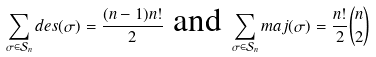Convert formula to latex. <formula><loc_0><loc_0><loc_500><loc_500>\sum _ { \sigma \in \mathcal { S } _ { n } } d e s ( \sigma ) = \frac { ( n - 1 ) n ! } { 2 } \ \text {and} \ \sum _ { \sigma \in \mathcal { S } _ { n } } m a j ( \sigma ) = \frac { n ! } { 2 } \binom { n } { 2 }</formula> 